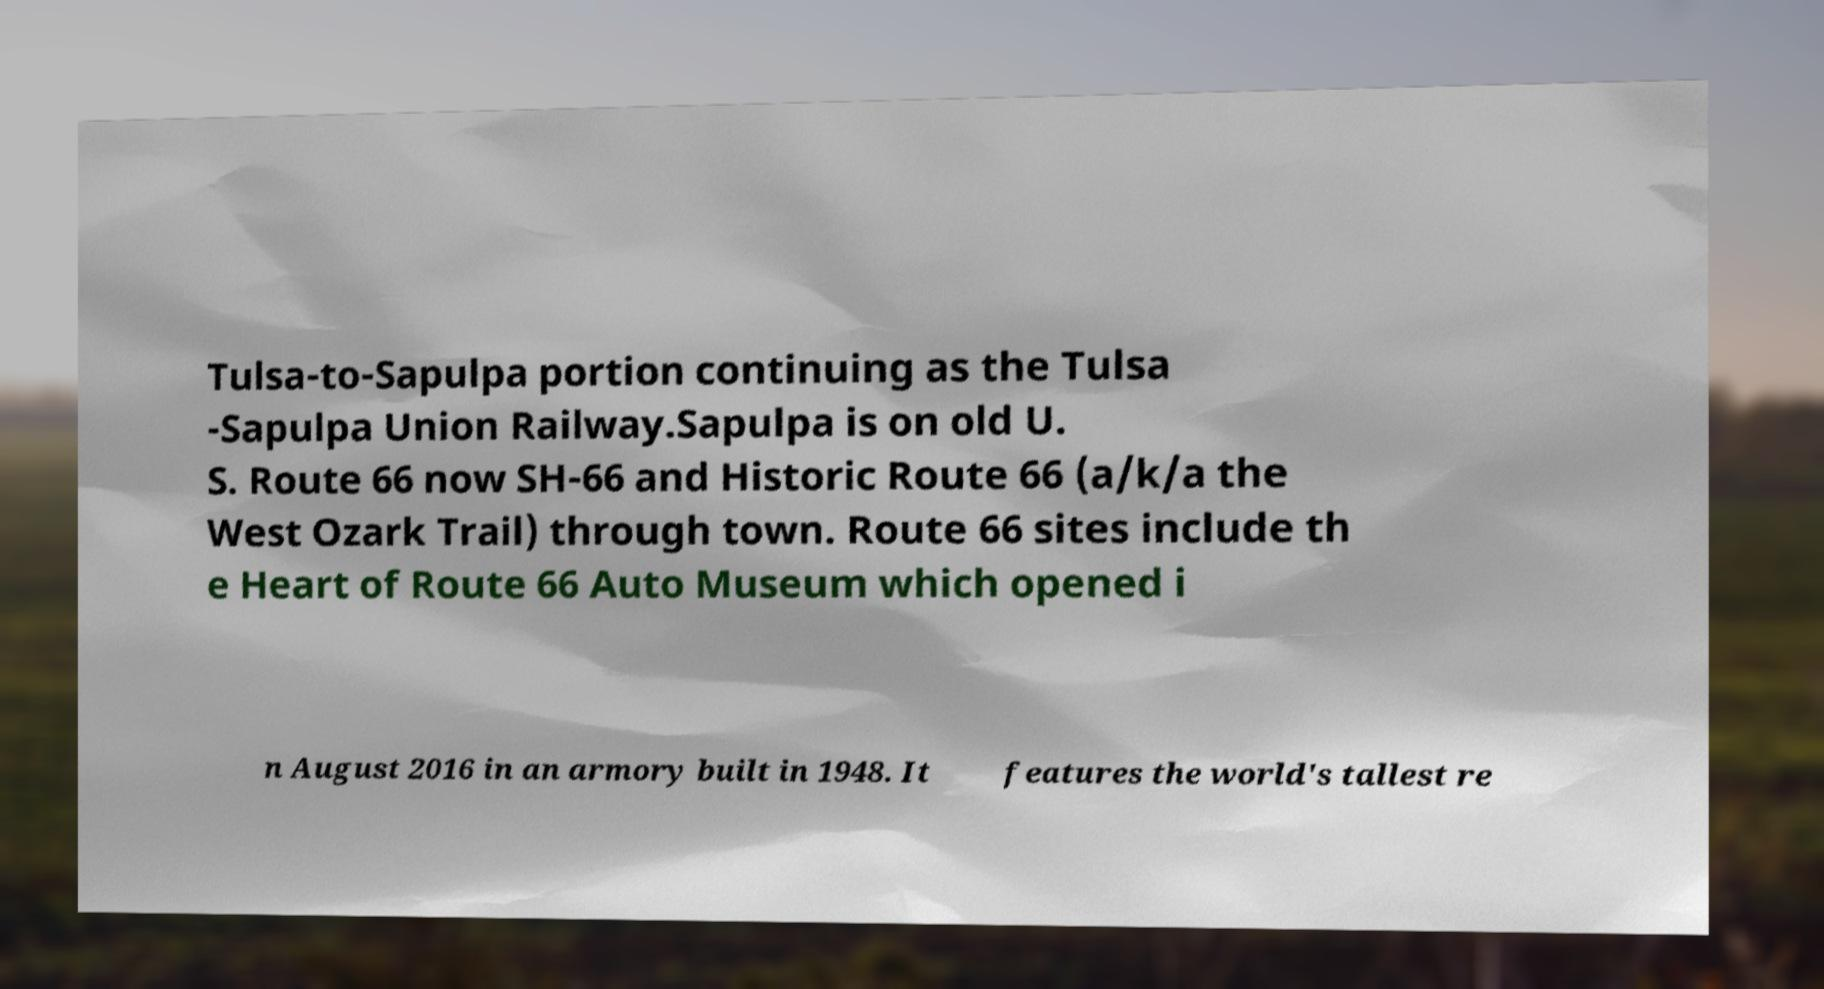Can you read and provide the text displayed in the image?This photo seems to have some interesting text. Can you extract and type it out for me? Tulsa-to-Sapulpa portion continuing as the Tulsa -Sapulpa Union Railway.Sapulpa is on old U. S. Route 66 now SH-66 and Historic Route 66 (a/k/a the West Ozark Trail) through town. Route 66 sites include th e Heart of Route 66 Auto Museum which opened i n August 2016 in an armory built in 1948. It features the world's tallest re 